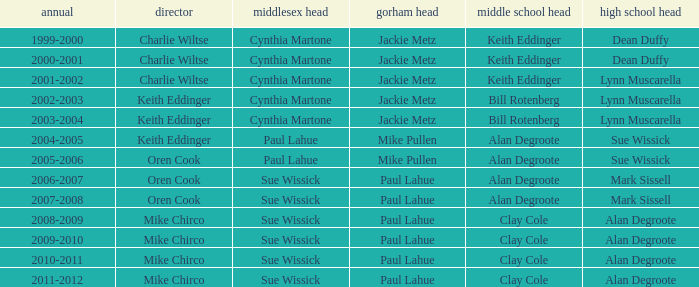How many middlesex principals were there in 2000-2001? 1.0. 